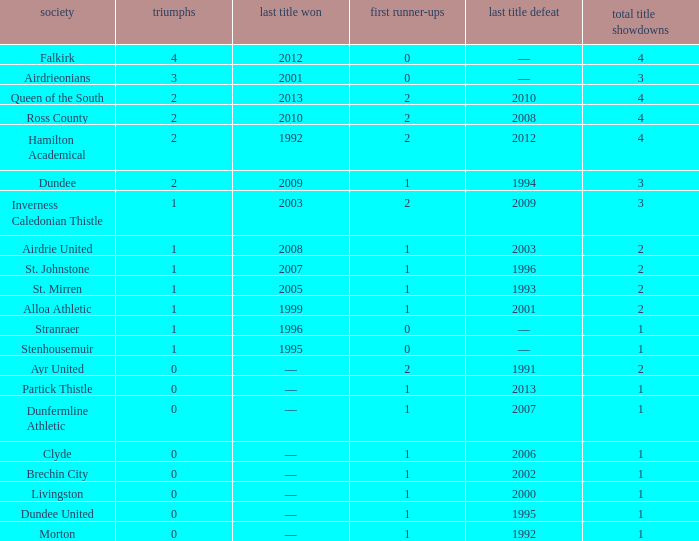What club has over 1 runners-up and last won the final in 2010? Ross County. 